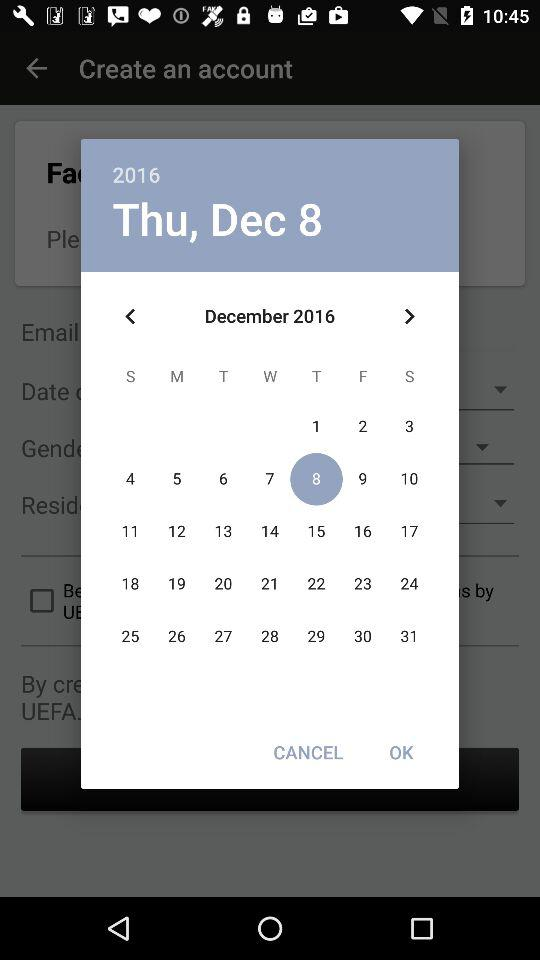What date was selected? The date is Thursday, December 8, 2016. 